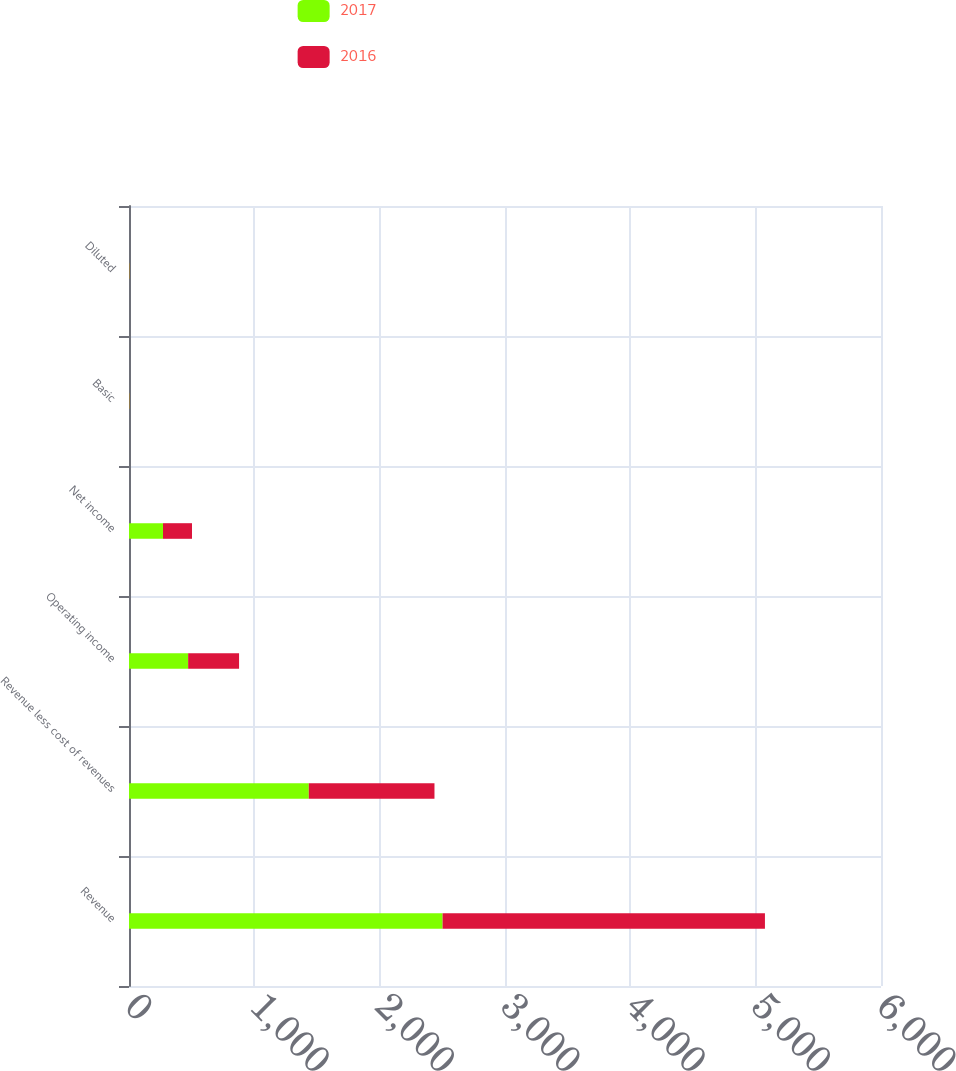Convert chart to OTSL. <chart><loc_0><loc_0><loc_500><loc_500><stacked_bar_chart><ecel><fcel>Revenue<fcel>Revenue less cost of revenues<fcel>Operating income<fcel>Net income<fcel>Basic<fcel>Diluted<nl><fcel>2017<fcel>2502<fcel>1434.5<fcel>471.9<fcel>271.1<fcel>2.41<fcel>2.41<nl><fcel>2016<fcel>2572<fcel>1002.8<fcel>406.3<fcel>231.6<fcel>2.06<fcel>2.06<nl></chart> 